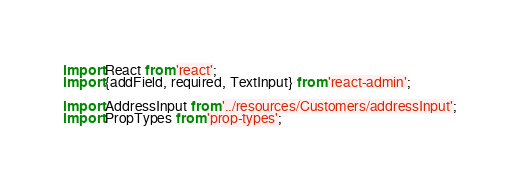Convert code to text. <code><loc_0><loc_0><loc_500><loc_500><_JavaScript_>import React from 'react';
import {addField, required, TextInput} from 'react-admin';

import AddressInput from '../resources/Customers/addressInput';
import PropTypes from 'prop-types';
</code> 